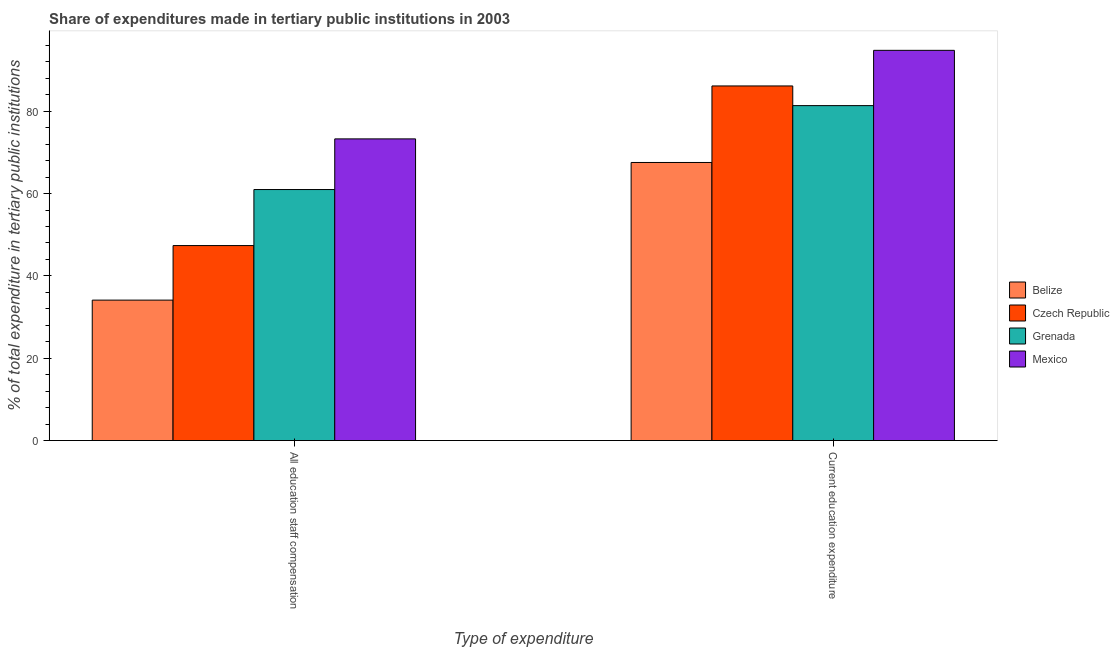How many different coloured bars are there?
Offer a very short reply. 4. Are the number of bars per tick equal to the number of legend labels?
Your answer should be very brief. Yes. Are the number of bars on each tick of the X-axis equal?
Offer a terse response. Yes. How many bars are there on the 1st tick from the left?
Offer a terse response. 4. How many bars are there on the 1st tick from the right?
Keep it short and to the point. 4. What is the label of the 2nd group of bars from the left?
Provide a short and direct response. Current education expenditure. What is the expenditure in staff compensation in Mexico?
Keep it short and to the point. 73.28. Across all countries, what is the maximum expenditure in education?
Keep it short and to the point. 94.78. Across all countries, what is the minimum expenditure in staff compensation?
Your answer should be compact. 34.11. In which country was the expenditure in education minimum?
Ensure brevity in your answer.  Belize. What is the total expenditure in staff compensation in the graph?
Your answer should be compact. 215.73. What is the difference between the expenditure in education in Grenada and that in Czech Republic?
Keep it short and to the point. -4.78. What is the difference between the expenditure in staff compensation in Czech Republic and the expenditure in education in Belize?
Ensure brevity in your answer.  -20.18. What is the average expenditure in staff compensation per country?
Offer a very short reply. 53.93. What is the difference between the expenditure in staff compensation and expenditure in education in Belize?
Give a very brief answer. -33.43. What is the ratio of the expenditure in education in Grenada to that in Czech Republic?
Your response must be concise. 0.94. Is the expenditure in staff compensation in Czech Republic less than that in Belize?
Your answer should be very brief. No. In how many countries, is the expenditure in staff compensation greater than the average expenditure in staff compensation taken over all countries?
Your answer should be very brief. 2. What does the 1st bar from the left in All education staff compensation represents?
Offer a very short reply. Belize. What does the 2nd bar from the right in All education staff compensation represents?
Your answer should be compact. Grenada. How many bars are there?
Offer a very short reply. 8. How many countries are there in the graph?
Offer a terse response. 4. What is the difference between two consecutive major ticks on the Y-axis?
Your answer should be very brief. 20. Does the graph contain any zero values?
Offer a very short reply. No. How many legend labels are there?
Ensure brevity in your answer.  4. How are the legend labels stacked?
Provide a short and direct response. Vertical. What is the title of the graph?
Keep it short and to the point. Share of expenditures made in tertiary public institutions in 2003. What is the label or title of the X-axis?
Keep it short and to the point. Type of expenditure. What is the label or title of the Y-axis?
Your answer should be very brief. % of total expenditure in tertiary public institutions. What is the % of total expenditure in tertiary public institutions in Belize in All education staff compensation?
Make the answer very short. 34.11. What is the % of total expenditure in tertiary public institutions of Czech Republic in All education staff compensation?
Provide a short and direct response. 47.36. What is the % of total expenditure in tertiary public institutions of Grenada in All education staff compensation?
Ensure brevity in your answer.  60.97. What is the % of total expenditure in tertiary public institutions in Mexico in All education staff compensation?
Your response must be concise. 73.28. What is the % of total expenditure in tertiary public institutions of Belize in Current education expenditure?
Offer a very short reply. 67.55. What is the % of total expenditure in tertiary public institutions of Czech Republic in Current education expenditure?
Make the answer very short. 86.13. What is the % of total expenditure in tertiary public institutions of Grenada in Current education expenditure?
Ensure brevity in your answer.  81.36. What is the % of total expenditure in tertiary public institutions of Mexico in Current education expenditure?
Ensure brevity in your answer.  94.78. Across all Type of expenditure, what is the maximum % of total expenditure in tertiary public institutions of Belize?
Give a very brief answer. 67.55. Across all Type of expenditure, what is the maximum % of total expenditure in tertiary public institutions of Czech Republic?
Offer a terse response. 86.13. Across all Type of expenditure, what is the maximum % of total expenditure in tertiary public institutions in Grenada?
Provide a succinct answer. 81.36. Across all Type of expenditure, what is the maximum % of total expenditure in tertiary public institutions of Mexico?
Offer a terse response. 94.78. Across all Type of expenditure, what is the minimum % of total expenditure in tertiary public institutions in Belize?
Ensure brevity in your answer.  34.11. Across all Type of expenditure, what is the minimum % of total expenditure in tertiary public institutions of Czech Republic?
Make the answer very short. 47.36. Across all Type of expenditure, what is the minimum % of total expenditure in tertiary public institutions in Grenada?
Offer a very short reply. 60.97. Across all Type of expenditure, what is the minimum % of total expenditure in tertiary public institutions of Mexico?
Make the answer very short. 73.28. What is the total % of total expenditure in tertiary public institutions in Belize in the graph?
Ensure brevity in your answer.  101.66. What is the total % of total expenditure in tertiary public institutions of Czech Republic in the graph?
Your answer should be very brief. 133.5. What is the total % of total expenditure in tertiary public institutions in Grenada in the graph?
Your answer should be compact. 142.33. What is the total % of total expenditure in tertiary public institutions in Mexico in the graph?
Give a very brief answer. 168.06. What is the difference between the % of total expenditure in tertiary public institutions of Belize in All education staff compensation and that in Current education expenditure?
Your response must be concise. -33.43. What is the difference between the % of total expenditure in tertiary public institutions in Czech Republic in All education staff compensation and that in Current education expenditure?
Ensure brevity in your answer.  -38.77. What is the difference between the % of total expenditure in tertiary public institutions in Grenada in All education staff compensation and that in Current education expenditure?
Your answer should be very brief. -20.38. What is the difference between the % of total expenditure in tertiary public institutions in Mexico in All education staff compensation and that in Current education expenditure?
Ensure brevity in your answer.  -21.51. What is the difference between the % of total expenditure in tertiary public institutions in Belize in All education staff compensation and the % of total expenditure in tertiary public institutions in Czech Republic in Current education expenditure?
Offer a terse response. -52.02. What is the difference between the % of total expenditure in tertiary public institutions in Belize in All education staff compensation and the % of total expenditure in tertiary public institutions in Grenada in Current education expenditure?
Provide a succinct answer. -47.24. What is the difference between the % of total expenditure in tertiary public institutions of Belize in All education staff compensation and the % of total expenditure in tertiary public institutions of Mexico in Current education expenditure?
Your answer should be very brief. -60.67. What is the difference between the % of total expenditure in tertiary public institutions in Czech Republic in All education staff compensation and the % of total expenditure in tertiary public institutions in Grenada in Current education expenditure?
Provide a succinct answer. -33.99. What is the difference between the % of total expenditure in tertiary public institutions in Czech Republic in All education staff compensation and the % of total expenditure in tertiary public institutions in Mexico in Current education expenditure?
Offer a terse response. -47.42. What is the difference between the % of total expenditure in tertiary public institutions of Grenada in All education staff compensation and the % of total expenditure in tertiary public institutions of Mexico in Current education expenditure?
Provide a short and direct response. -33.81. What is the average % of total expenditure in tertiary public institutions in Belize per Type of expenditure?
Your answer should be very brief. 50.83. What is the average % of total expenditure in tertiary public institutions of Czech Republic per Type of expenditure?
Provide a short and direct response. 66.75. What is the average % of total expenditure in tertiary public institutions of Grenada per Type of expenditure?
Your response must be concise. 71.17. What is the average % of total expenditure in tertiary public institutions of Mexico per Type of expenditure?
Offer a terse response. 84.03. What is the difference between the % of total expenditure in tertiary public institutions in Belize and % of total expenditure in tertiary public institutions in Czech Republic in All education staff compensation?
Provide a succinct answer. -13.25. What is the difference between the % of total expenditure in tertiary public institutions of Belize and % of total expenditure in tertiary public institutions of Grenada in All education staff compensation?
Provide a short and direct response. -26.86. What is the difference between the % of total expenditure in tertiary public institutions in Belize and % of total expenditure in tertiary public institutions in Mexico in All education staff compensation?
Keep it short and to the point. -39.16. What is the difference between the % of total expenditure in tertiary public institutions of Czech Republic and % of total expenditure in tertiary public institutions of Grenada in All education staff compensation?
Your answer should be very brief. -13.61. What is the difference between the % of total expenditure in tertiary public institutions in Czech Republic and % of total expenditure in tertiary public institutions in Mexico in All education staff compensation?
Keep it short and to the point. -25.91. What is the difference between the % of total expenditure in tertiary public institutions of Grenada and % of total expenditure in tertiary public institutions of Mexico in All education staff compensation?
Make the answer very short. -12.3. What is the difference between the % of total expenditure in tertiary public institutions in Belize and % of total expenditure in tertiary public institutions in Czech Republic in Current education expenditure?
Offer a very short reply. -18.59. What is the difference between the % of total expenditure in tertiary public institutions in Belize and % of total expenditure in tertiary public institutions in Grenada in Current education expenditure?
Offer a terse response. -13.81. What is the difference between the % of total expenditure in tertiary public institutions of Belize and % of total expenditure in tertiary public institutions of Mexico in Current education expenditure?
Your response must be concise. -27.24. What is the difference between the % of total expenditure in tertiary public institutions of Czech Republic and % of total expenditure in tertiary public institutions of Grenada in Current education expenditure?
Provide a succinct answer. 4.78. What is the difference between the % of total expenditure in tertiary public institutions of Czech Republic and % of total expenditure in tertiary public institutions of Mexico in Current education expenditure?
Ensure brevity in your answer.  -8.65. What is the difference between the % of total expenditure in tertiary public institutions of Grenada and % of total expenditure in tertiary public institutions of Mexico in Current education expenditure?
Provide a short and direct response. -13.43. What is the ratio of the % of total expenditure in tertiary public institutions of Belize in All education staff compensation to that in Current education expenditure?
Ensure brevity in your answer.  0.51. What is the ratio of the % of total expenditure in tertiary public institutions in Czech Republic in All education staff compensation to that in Current education expenditure?
Ensure brevity in your answer.  0.55. What is the ratio of the % of total expenditure in tertiary public institutions of Grenada in All education staff compensation to that in Current education expenditure?
Give a very brief answer. 0.75. What is the ratio of the % of total expenditure in tertiary public institutions of Mexico in All education staff compensation to that in Current education expenditure?
Provide a succinct answer. 0.77. What is the difference between the highest and the second highest % of total expenditure in tertiary public institutions in Belize?
Offer a terse response. 33.43. What is the difference between the highest and the second highest % of total expenditure in tertiary public institutions in Czech Republic?
Ensure brevity in your answer.  38.77. What is the difference between the highest and the second highest % of total expenditure in tertiary public institutions in Grenada?
Provide a succinct answer. 20.38. What is the difference between the highest and the second highest % of total expenditure in tertiary public institutions of Mexico?
Make the answer very short. 21.51. What is the difference between the highest and the lowest % of total expenditure in tertiary public institutions in Belize?
Your answer should be very brief. 33.43. What is the difference between the highest and the lowest % of total expenditure in tertiary public institutions in Czech Republic?
Your answer should be very brief. 38.77. What is the difference between the highest and the lowest % of total expenditure in tertiary public institutions in Grenada?
Offer a terse response. 20.38. What is the difference between the highest and the lowest % of total expenditure in tertiary public institutions of Mexico?
Make the answer very short. 21.51. 